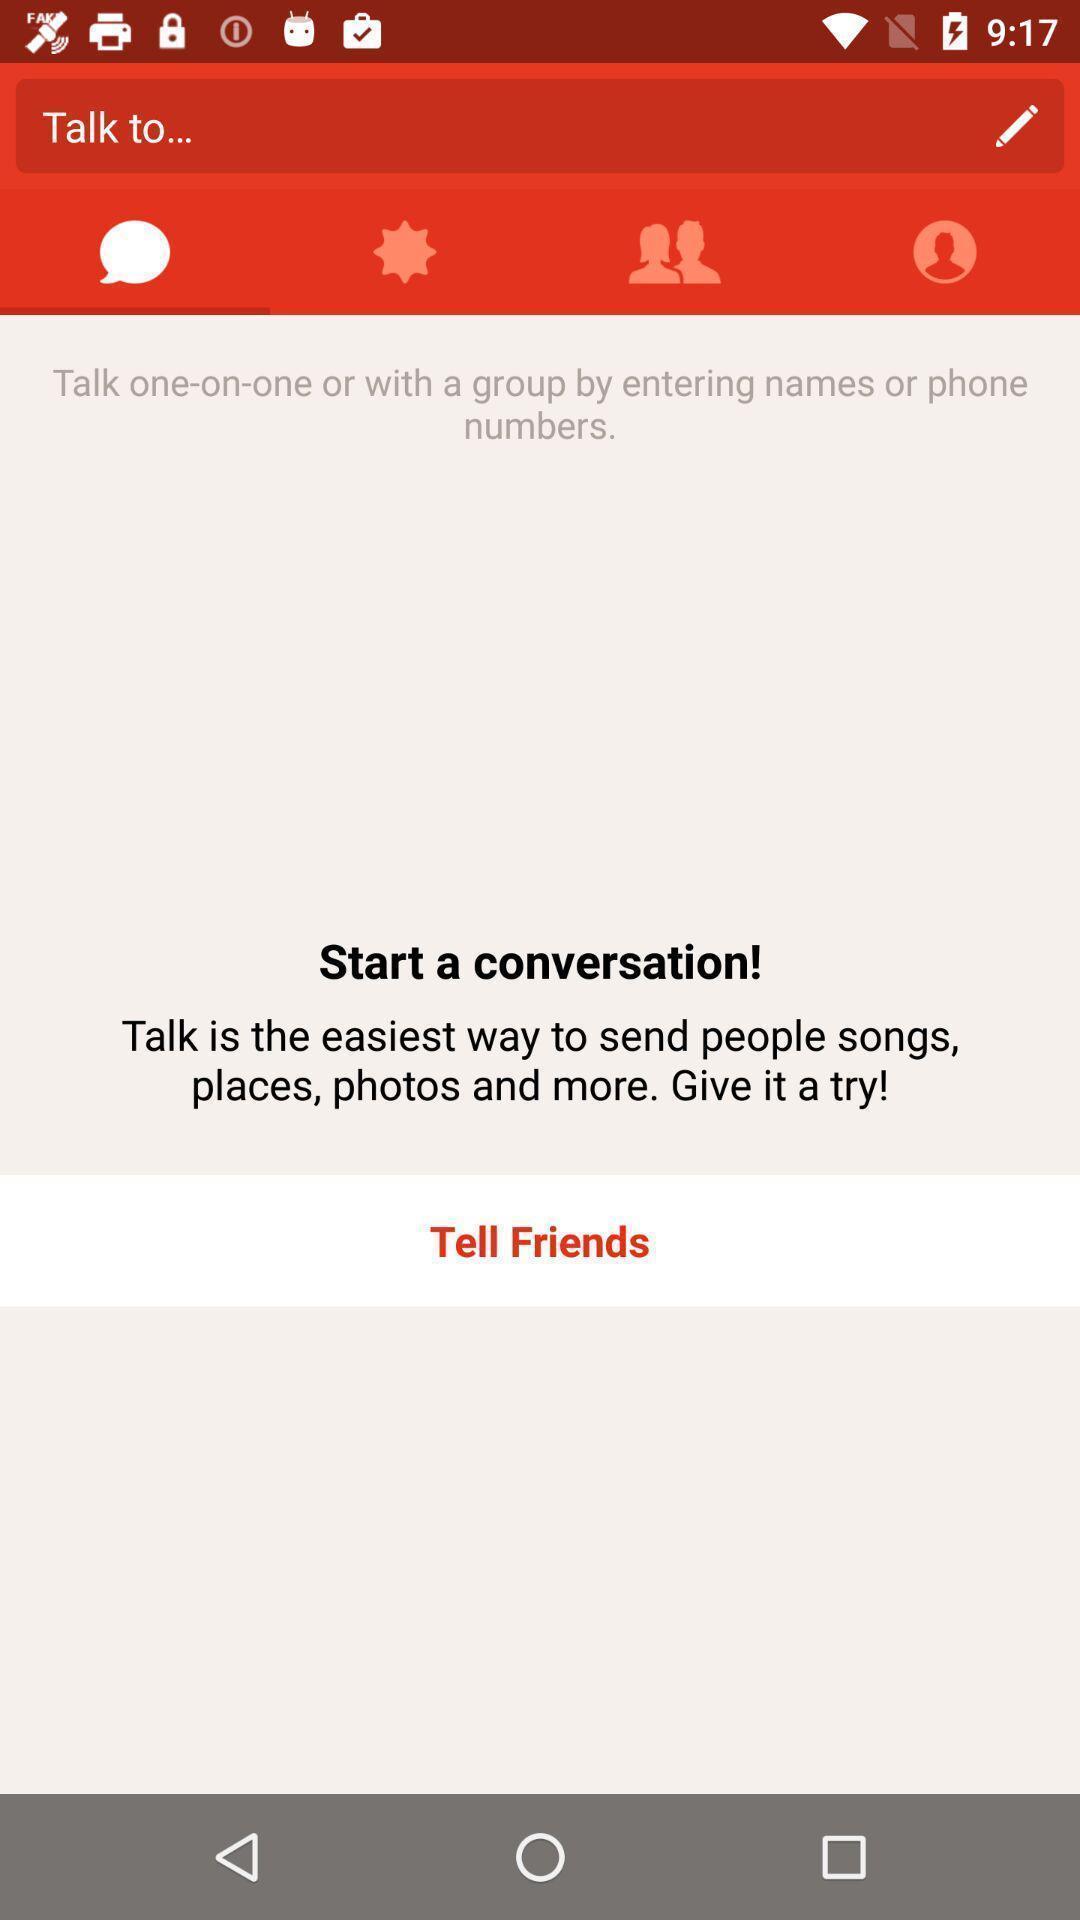Describe the key features of this screenshot. Screen displaying a search bar in a chatting application. 